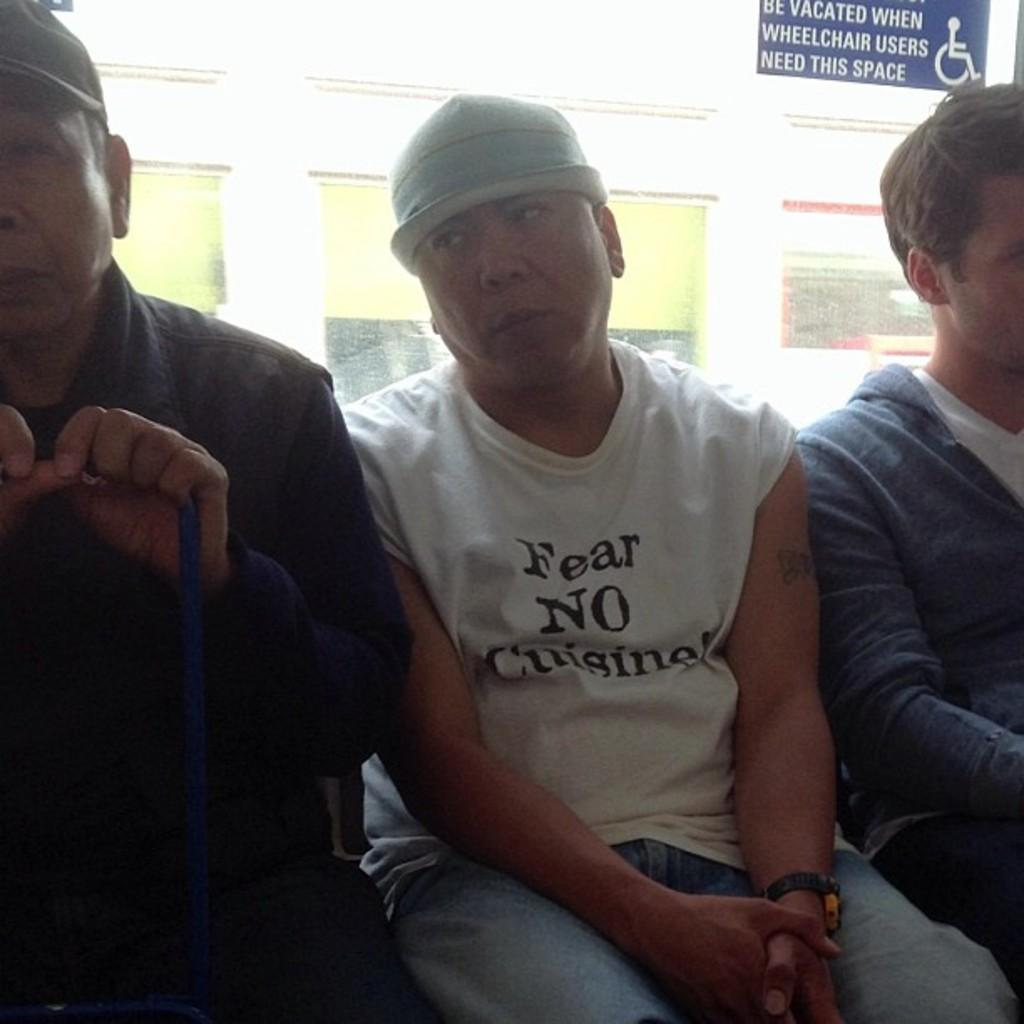How many people are sitting in the image? There are three persons sitting in the image. What can be seen in the background of the image? There is a wall with wall paintings and a board in the background of the image. Can you describe the setting of the image? The image may have been taken in a hall, as suggested by the presence of a wall and a board. What type of shoes are the middle person wearing in the image? There is no information about shoes or any person being in the middle in the image. 